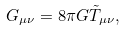Convert formula to latex. <formula><loc_0><loc_0><loc_500><loc_500>G _ { \mu \nu } = 8 \pi G \tilde { T } _ { \mu \nu } ,</formula> 